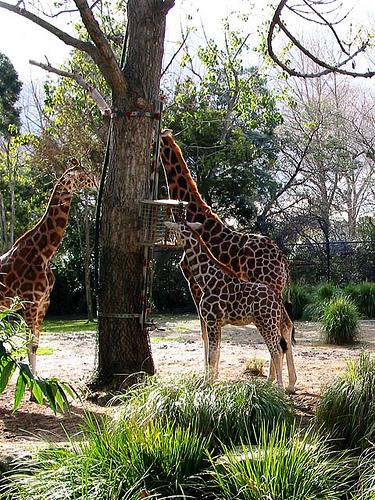Do all of the animals appear the same age?
Answer briefly. No. Is this the giraffes natural habitat?
Concise answer only. No. What are the giraffes eating from?
Answer briefly. Feeders. 